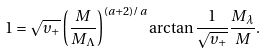Convert formula to latex. <formula><loc_0><loc_0><loc_500><loc_500>1 = \sqrt { \upsilon _ { + } } \left ( \frac { M } { M _ { \Lambda } } \right ) ^ { ( a + 2 ) / a } \arctan \frac { 1 } { \sqrt { \upsilon _ { + } } } \frac { M _ { \lambda } } { M } .</formula> 